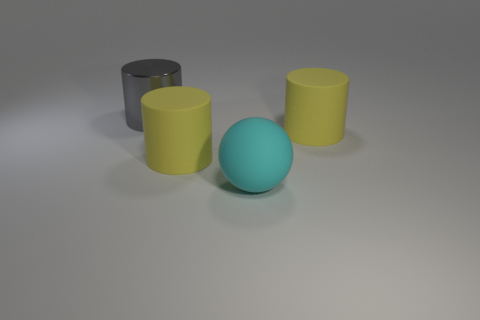Add 2 gray cylinders. How many objects exist? 6 Subtract all balls. How many objects are left? 3 Subtract all large cyan metal balls. Subtract all big gray cylinders. How many objects are left? 3 Add 4 yellow cylinders. How many yellow cylinders are left? 6 Add 4 big matte things. How many big matte things exist? 7 Subtract 0 cyan cylinders. How many objects are left? 4 